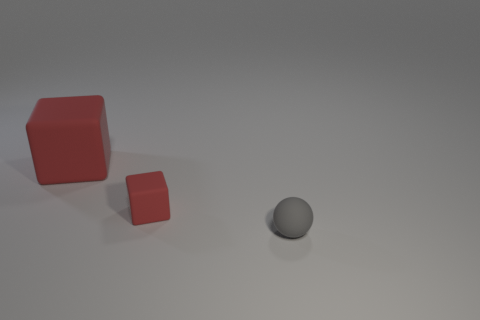Is the number of green rubber cylinders less than the number of matte blocks?
Offer a terse response. Yes. Is there anything else that has the same color as the small matte ball?
Keep it short and to the point. No. How big is the matte object behind the small red cube?
Provide a succinct answer. Large. Are there more blue balls than large red matte things?
Your answer should be compact. No. What is the tiny red thing made of?
Give a very brief answer. Rubber. How many other things are there of the same material as the gray sphere?
Offer a very short reply. 2. How many tiny cyan matte objects are there?
Provide a short and direct response. 0. There is a tiny thing that is the same shape as the large thing; what material is it?
Ensure brevity in your answer.  Rubber. Do the red object right of the large red object and the small gray ball have the same material?
Keep it short and to the point. Yes. Are there more red blocks behind the tiny red rubber cube than things that are behind the large red thing?
Your response must be concise. Yes. 